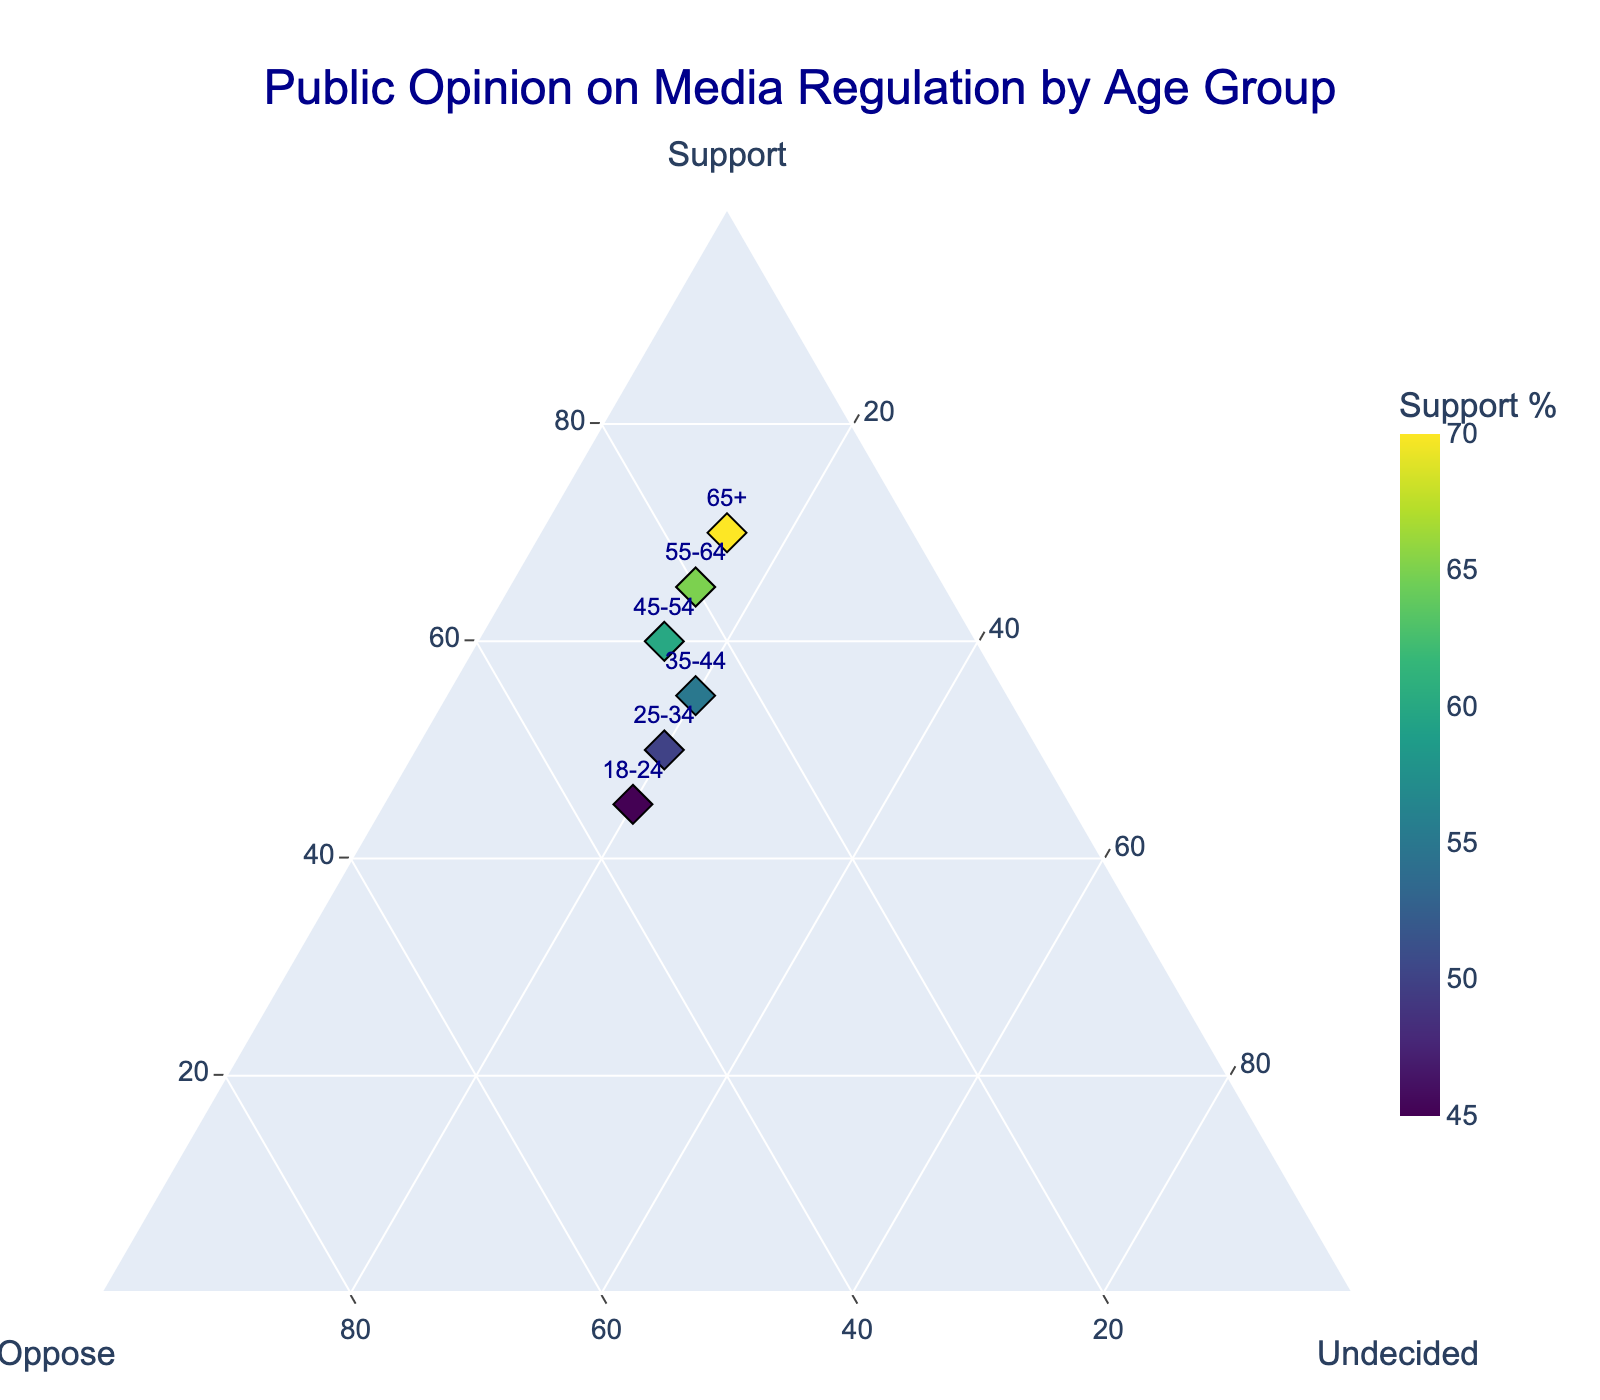What is the title of the plot? The title of the plot is generally located at the top center of the figure. In this case, it provides context on the data being presented.
Answer: Public Opinion on Media Regulation by Age Group Which age group has the highest percentage of people supporting media regulation? Observing the "Support" axis, the group with the highest value in this category is marked visually. Here, the 65+ age group has the highest support at 70%.
Answer: 65+ What is the percentage difference in support between the 18-24 and 55-64 age groups? First, locate the support percentages for both groups: 45% for 18-24 and 65% for 55-64. Subtracting these values gives the difference. 65 - 45 = 20
Answer: 20% Which age group shows the least opposition to media regulation? By examining the "Oppose" axis, we see which group has the smallest value. Here, the 65+ age group has the least opposition at 15%.
Answer: 65+ How many data points are plotted on the figure? Each age group represents one data point. Counting the number of age groups listed gives the total data points. There are six age groups.
Answer: 6 What is the range of the "Undecided" percentages across all age groups? Find the minimum and maximum values in the "Undecided" category. Both the minimum and maximum undecided percentages are 15%, so the range is 0%.
Answer: 0% Which age groups have an equal percentage of undecided opinions? We look for age groups with the same undecided percentages. From the figure, 35-44, 45-54, 55-64, and 65+ all have 15% undecided.
Answer: 35-44, 45-54, 55-64, 65+ How does the percentage of opposition for the 25-34 age group compare to that of the 45-54 age group? Locate the opposition percentages for these groups: 30% for 25-34 and 25% for 45-54. Comparing these values shows that the opposition is higher in the 25-34 age group.
Answer: Higher in 25-34 What is the average support percentage across all age groups? Add the support percentages (45 + 50 + 55 + 60 + 65 + 70) and divide by the number of age groups (6). The calculation gives (345 / 6) = 57.5%.
Answer: 57.5% How do the color indicators assist in interpreting the plot? The colors correlate to the support percentages, with a color gradient (Viridis) visually distinguishing different levels of support, providing an at-a-glance understanding.
Answer: Indicate support levels 